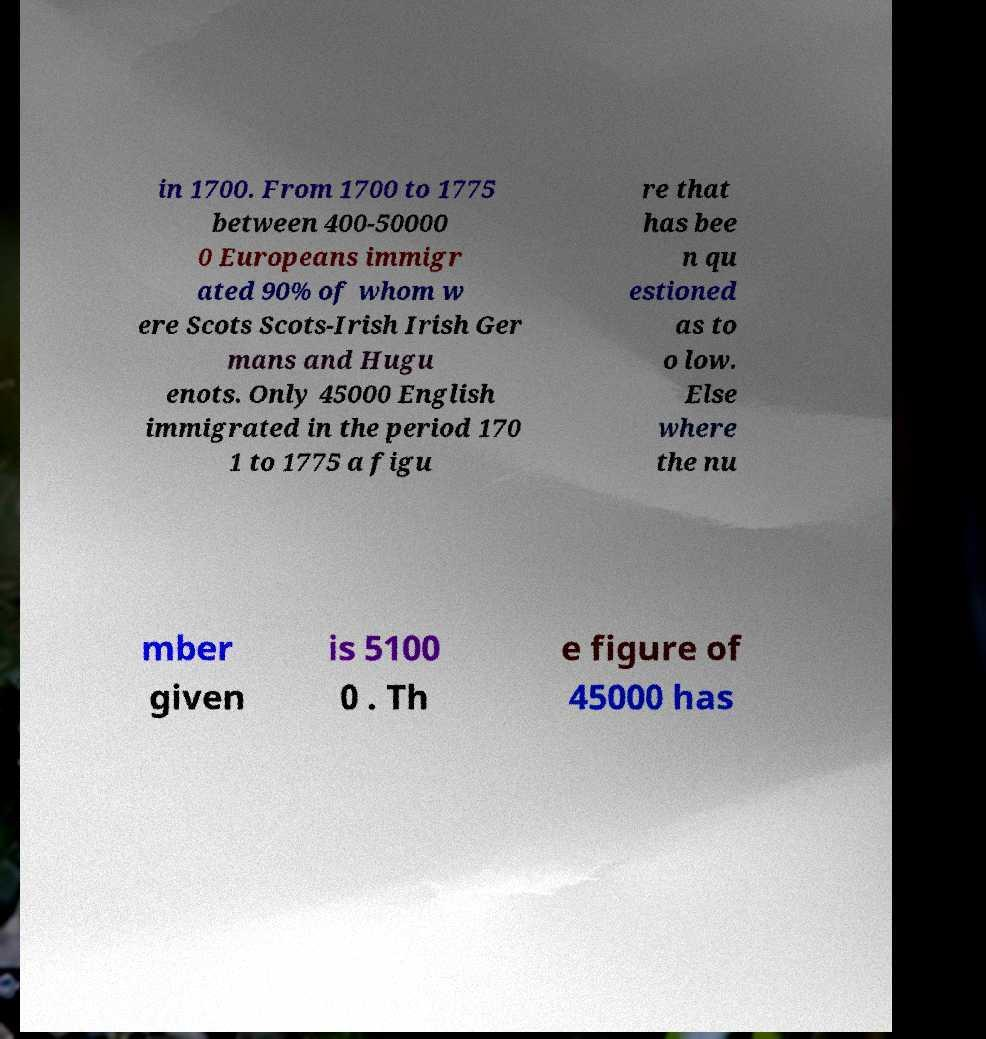There's text embedded in this image that I need extracted. Can you transcribe it verbatim? in 1700. From 1700 to 1775 between 400-50000 0 Europeans immigr ated 90% of whom w ere Scots Scots-Irish Irish Ger mans and Hugu enots. Only 45000 English immigrated in the period 170 1 to 1775 a figu re that has bee n qu estioned as to o low. Else where the nu mber given is 5100 0 . Th e figure of 45000 has 